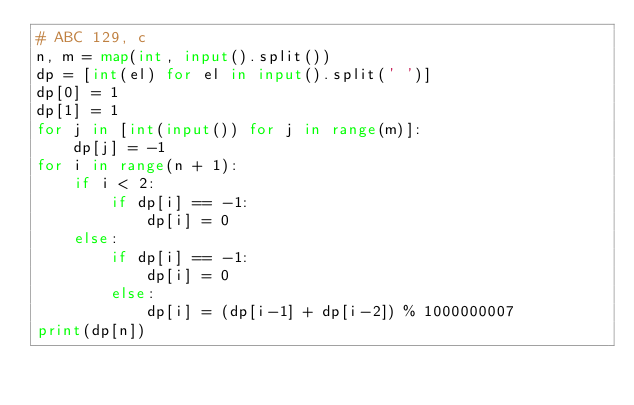<code> <loc_0><loc_0><loc_500><loc_500><_Python_># ABC 129, c
n, m = map(int, input().split())
dp = [int(el) for el in input().split(' ')]
dp[0] = 1
dp[1] = 1
for j in [int(input()) for j in range(m)]:
    dp[j] = -1
for i in range(n + 1):
    if i < 2:
        if dp[i] == -1:
            dp[i] = 0
    else:
        if dp[i] == -1:
            dp[i] = 0
        else:
            dp[i] = (dp[i-1] + dp[i-2]) % 1000000007
print(dp[n])
</code> 